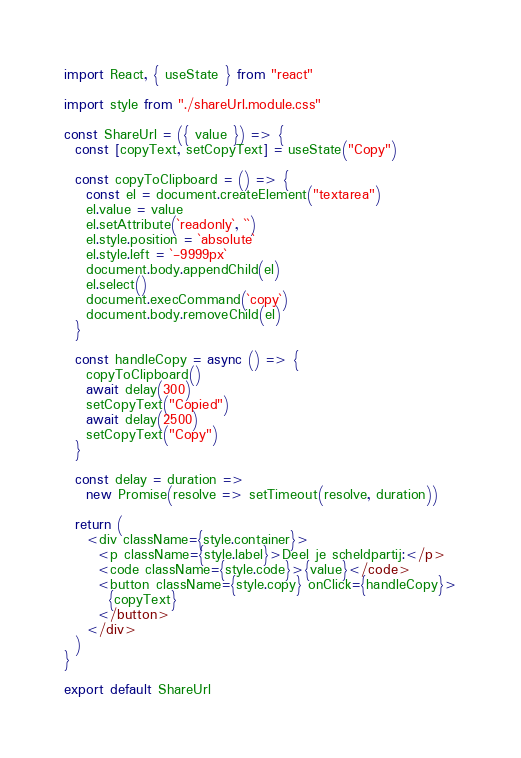<code> <loc_0><loc_0><loc_500><loc_500><_JavaScript_>import React, { useState } from "react"

import style from "./shareUrl.module.css"

const ShareUrl = ({ value }) => {
  const [copyText, setCopyText] = useState("Copy")

  const copyToClipboard = () => {
    const el = document.createElement("textarea")
    el.value = value
    el.setAttribute(`readonly`, ``)
    el.style.position = `absolute`
    el.style.left = `-9999px`
    document.body.appendChild(el)
    el.select()
    document.execCommand(`copy`)
    document.body.removeChild(el)
  }

  const handleCopy = async () => {
    copyToClipboard()
    await delay(300)
    setCopyText("Copied")
    await delay(2500)
    setCopyText("Copy")
  }

  const delay = duration =>
    new Promise(resolve => setTimeout(resolve, duration))

  return (
    <div className={style.container}>
      <p className={style.label}>Deel je scheldpartij:</p>
      <code className={style.code}>{value}</code>
      <button className={style.copy} onClick={handleCopy}>
        {copyText}
      </button>
    </div>
  )
}

export default ShareUrl
</code> 